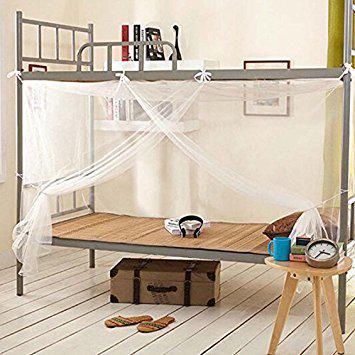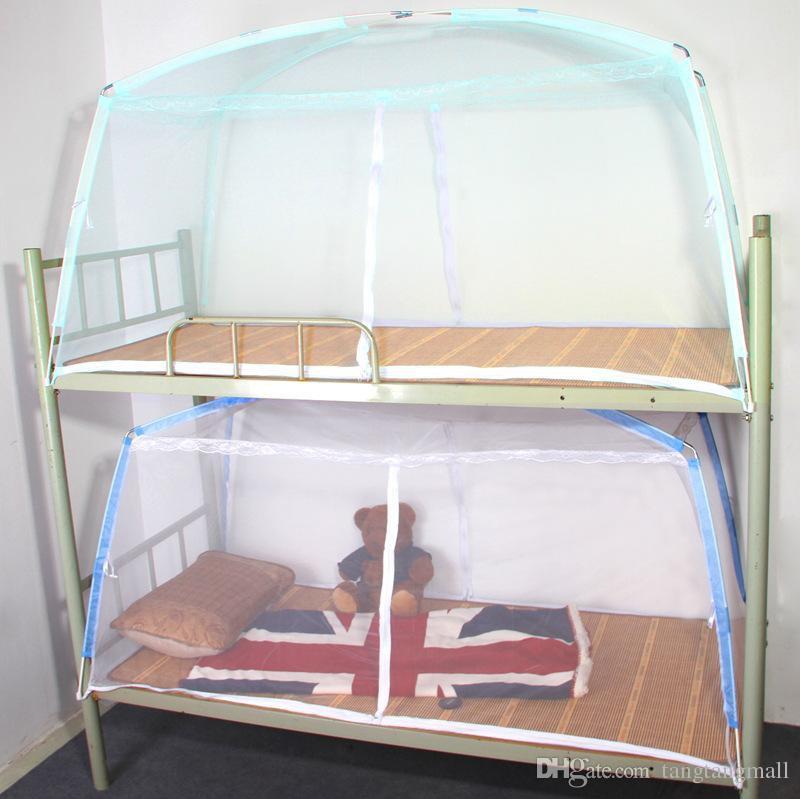The first image is the image on the left, the second image is the image on the right. Evaluate the accuracy of this statement regarding the images: "An image shows a ceiling-suspended tent-shaped gauze canopy over bunk beds.". Is it true? Answer yes or no. No. 